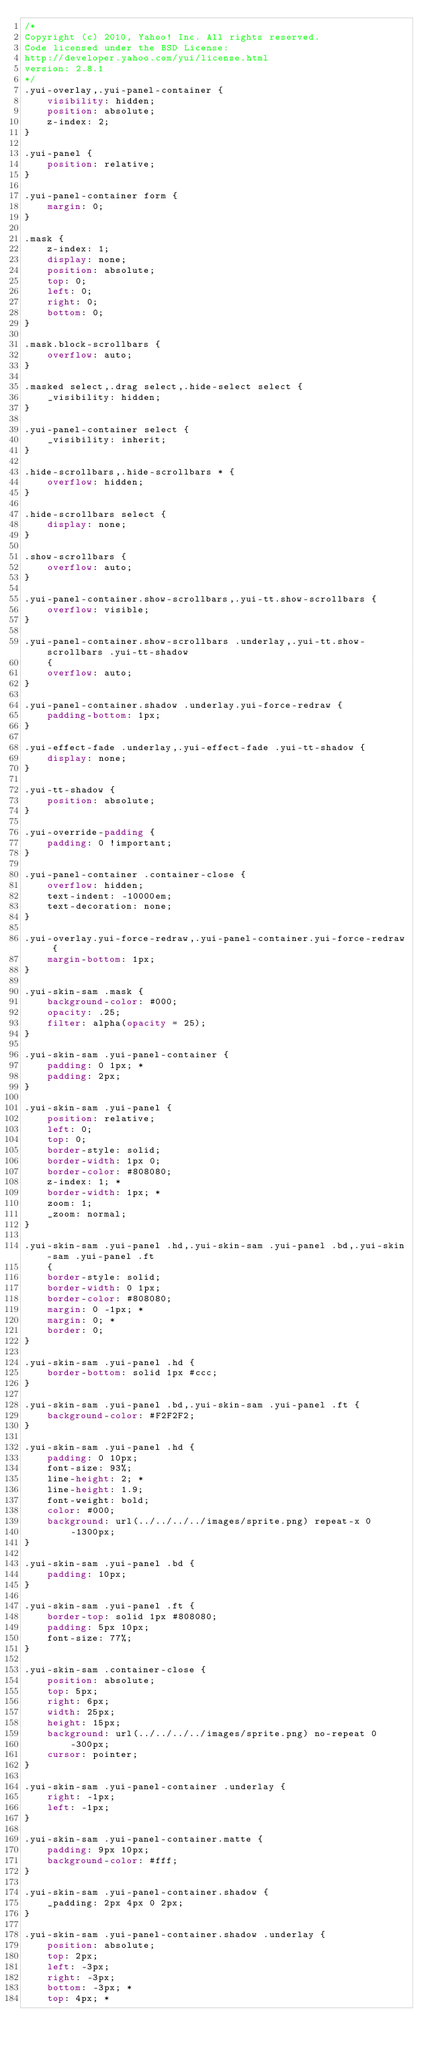Convert code to text. <code><loc_0><loc_0><loc_500><loc_500><_CSS_>/*
Copyright (c) 2010, Yahoo! Inc. All rights reserved.
Code licensed under the BSD License:
http://developer.yahoo.com/yui/license.html
version: 2.8.1
*/
.yui-overlay,.yui-panel-container {
	visibility: hidden;
	position: absolute;
	z-index: 2;
}

.yui-panel {
	position: relative;
}

.yui-panel-container form {
	margin: 0;
}

.mask {
	z-index: 1;
	display: none;
	position: absolute;
	top: 0;
	left: 0;
	right: 0;
	bottom: 0;
}

.mask.block-scrollbars {
	overflow: auto;
}

.masked select,.drag select,.hide-select select {
	_visibility: hidden;
}

.yui-panel-container select {
	_visibility: inherit;
}

.hide-scrollbars,.hide-scrollbars * {
	overflow: hidden;
}

.hide-scrollbars select {
	display: none;
}

.show-scrollbars {
	overflow: auto;
}

.yui-panel-container.show-scrollbars,.yui-tt.show-scrollbars {
	overflow: visible;
}

.yui-panel-container.show-scrollbars .underlay,.yui-tt.show-scrollbars .yui-tt-shadow
	{
	overflow: auto;
}

.yui-panel-container.shadow .underlay.yui-force-redraw {
	padding-bottom: 1px;
}

.yui-effect-fade .underlay,.yui-effect-fade .yui-tt-shadow {
	display: none;
}

.yui-tt-shadow {
	position: absolute;
}

.yui-override-padding {
	padding: 0 !important;
}

.yui-panel-container .container-close {
	overflow: hidden;
	text-indent: -10000em;
	text-decoration: none;
}

.yui-overlay.yui-force-redraw,.yui-panel-container.yui-force-redraw {
	margin-bottom: 1px;
}

.yui-skin-sam .mask {
	background-color: #000;
	opacity: .25;
	filter: alpha(opacity = 25);
}

.yui-skin-sam .yui-panel-container {
	padding: 0 1px; *
	padding: 2px;
}

.yui-skin-sam .yui-panel {
	position: relative;
	left: 0;
	top: 0;
	border-style: solid;
	border-width: 1px 0;
	border-color: #808080;
	z-index: 1; *
	border-width: 1px; *
	zoom: 1;
	_zoom: normal;
}

.yui-skin-sam .yui-panel .hd,.yui-skin-sam .yui-panel .bd,.yui-skin-sam .yui-panel .ft
	{
	border-style: solid;
	border-width: 0 1px;
	border-color: #808080;
	margin: 0 -1px; *
	margin: 0; *
	border: 0;
}

.yui-skin-sam .yui-panel .hd {
	border-bottom: solid 1px #ccc;
}

.yui-skin-sam .yui-panel .bd,.yui-skin-sam .yui-panel .ft {
	background-color: #F2F2F2;
}

.yui-skin-sam .yui-panel .hd {
	padding: 0 10px;
	font-size: 93%;
	line-height: 2; *
	line-height: 1.9;
	font-weight: bold;
	color: #000;
	background: url(../../../../images/sprite.png) repeat-x 0
		-1300px;
}

.yui-skin-sam .yui-panel .bd {
	padding: 10px;
}

.yui-skin-sam .yui-panel .ft {
	border-top: solid 1px #808080;
	padding: 5px 10px;
	font-size: 77%;
}

.yui-skin-sam .container-close {
	position: absolute;
	top: 5px;
	right: 6px;
	width: 25px;
	height: 15px;
	background: url(../../../../images/sprite.png) no-repeat 0
		-300px;
	cursor: pointer;
}

.yui-skin-sam .yui-panel-container .underlay {
	right: -1px;
	left: -1px;
}

.yui-skin-sam .yui-panel-container.matte {
	padding: 9px 10px;
	background-color: #fff;
}

.yui-skin-sam .yui-panel-container.shadow {
	_padding: 2px 4px 0 2px;
}

.yui-skin-sam .yui-panel-container.shadow .underlay {
	position: absolute;
	top: 2px;
	left: -3px;
	right: -3px;
	bottom: -3px; *
	top: 4px; *</code> 